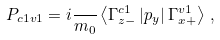<formula> <loc_0><loc_0><loc_500><loc_500>P _ { c 1 v 1 } = i \frac { } { m _ { 0 } } \left \langle \Gamma _ { z - } ^ { c 1 } \left | p _ { y } \right | \Gamma _ { x + } ^ { v 1 } \right \rangle \, ,</formula> 